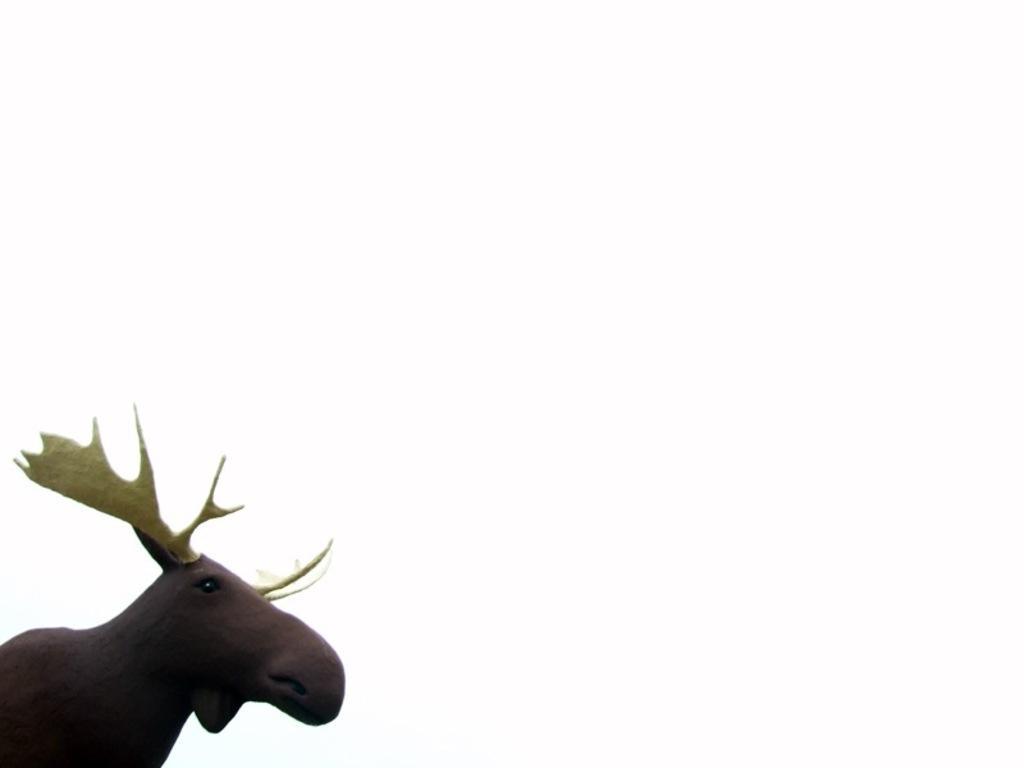Could you give a brief overview of what you see in this image? In the picture we can see a sculpture of a stag which is brown in color and horns are yellow in color. 